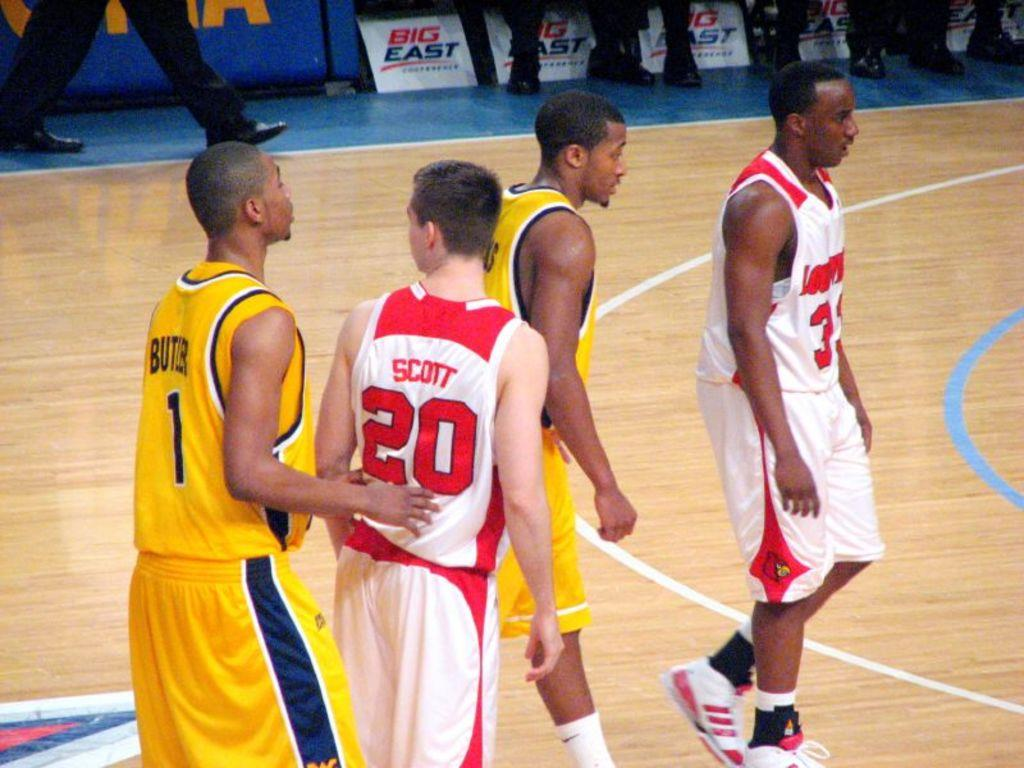How many people are present in the image? There are four people standing in the image. What can be seen in the background of the image? There is a group of people and boards visible in the background of the image. What type of shoes are the people wearing in the image? There is no information about the shoes the people are wearing in the image. 